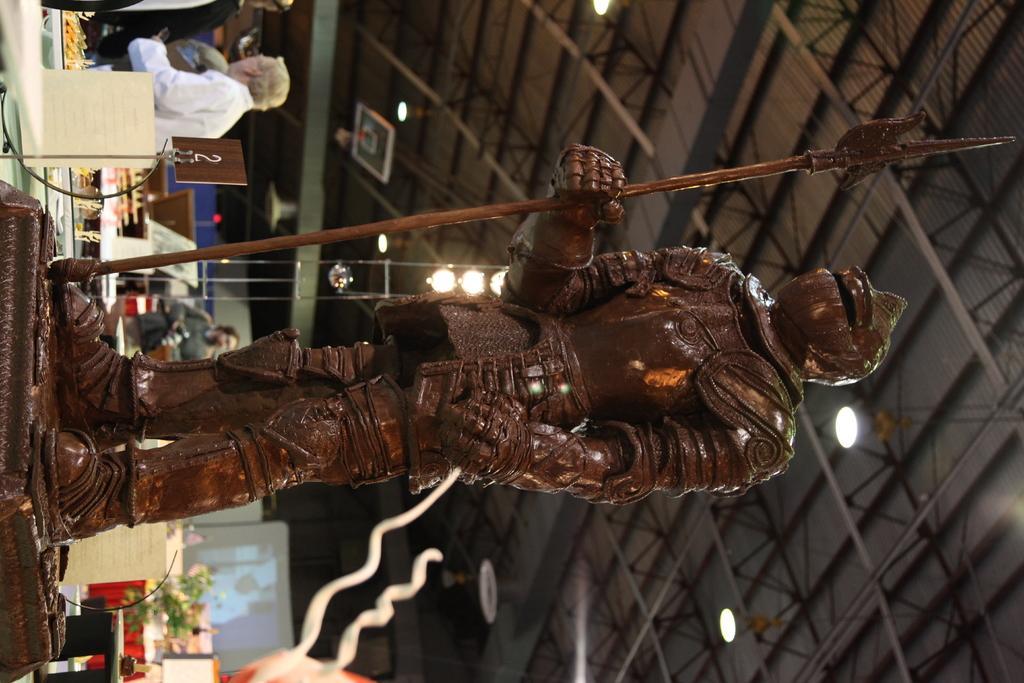In one or two sentences, can you explain what this image depicts? This is a tilted picture. We can see roof, lights, statue, people, projector screen and few other objects. 